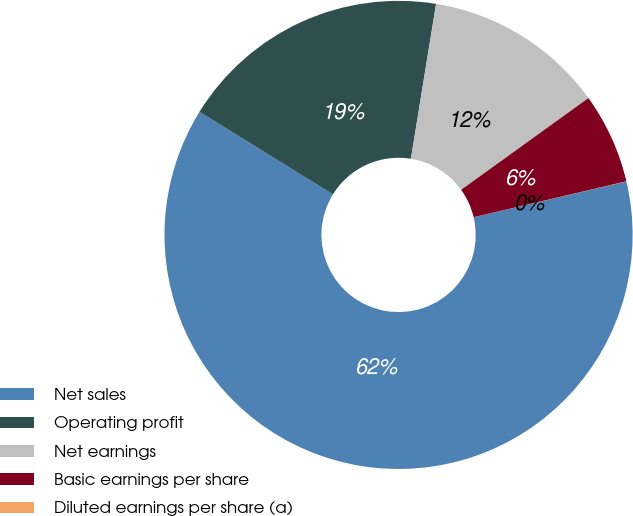Convert chart to OTSL. <chart><loc_0><loc_0><loc_500><loc_500><pie_chart><fcel>Net sales<fcel>Operating profit<fcel>Net earnings<fcel>Basic earnings per share<fcel>Diluted earnings per share (a)<nl><fcel>62.48%<fcel>18.75%<fcel>12.5%<fcel>6.26%<fcel>0.01%<nl></chart> 